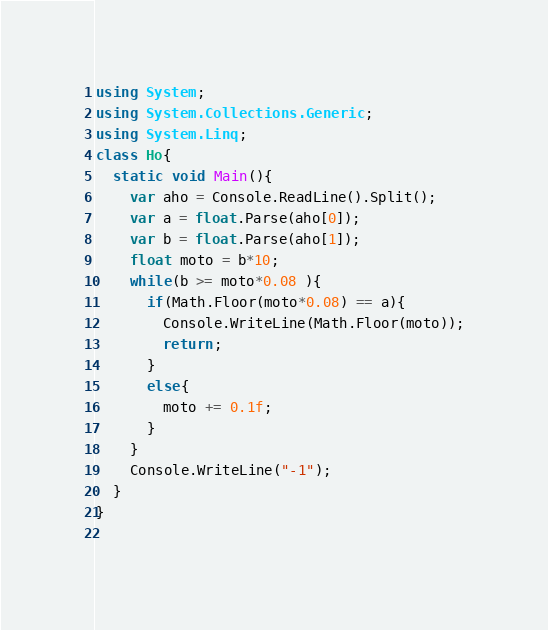Convert code to text. <code><loc_0><loc_0><loc_500><loc_500><_C#_>using System;
using System.Collections.Generic;
using System.Linq;
class Ho{
  static void Main(){
    var aho = Console.ReadLine().Split();
    var a = float.Parse(aho[0]);
    var b = float.Parse(aho[1]);
    float moto = b*10;
    while(b >= moto*0.08 ){
      if(Math.Floor(moto*0.08) == a){
        Console.WriteLine(Math.Floor(moto));
        return;
      }
      else{
        moto += 0.1f;
      }
    } 
    Console.WriteLine("-1");
  }
}
 </code> 